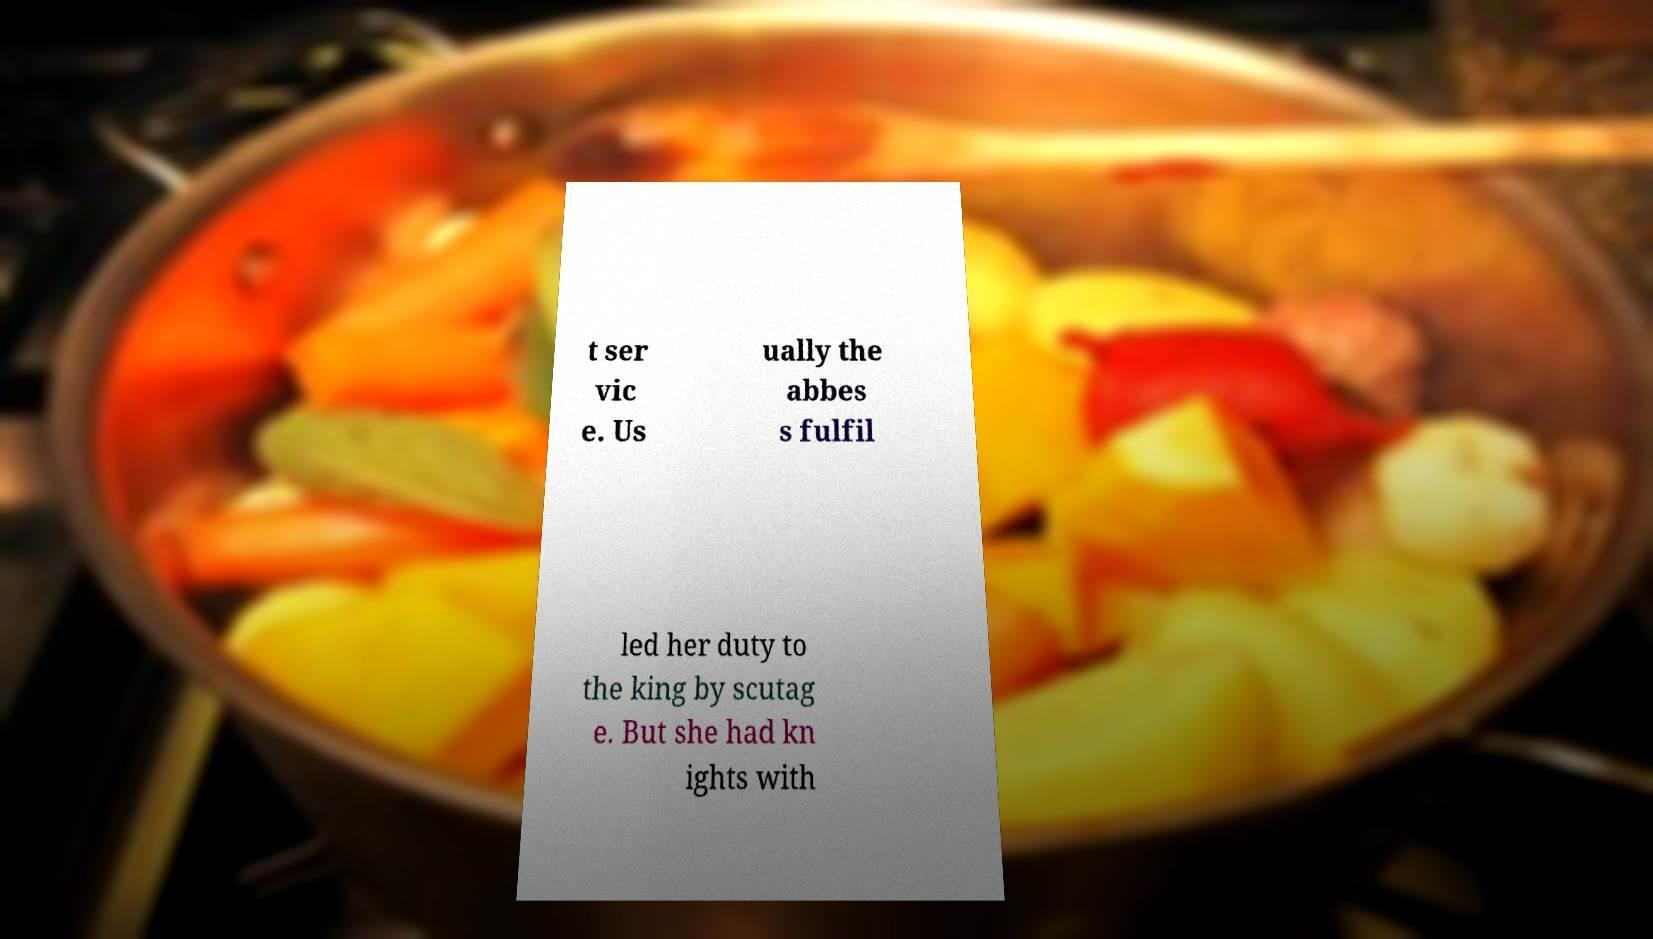I need the written content from this picture converted into text. Can you do that? t ser vic e. Us ually the abbes s fulfil led her duty to the king by scutag e. But she had kn ights with 